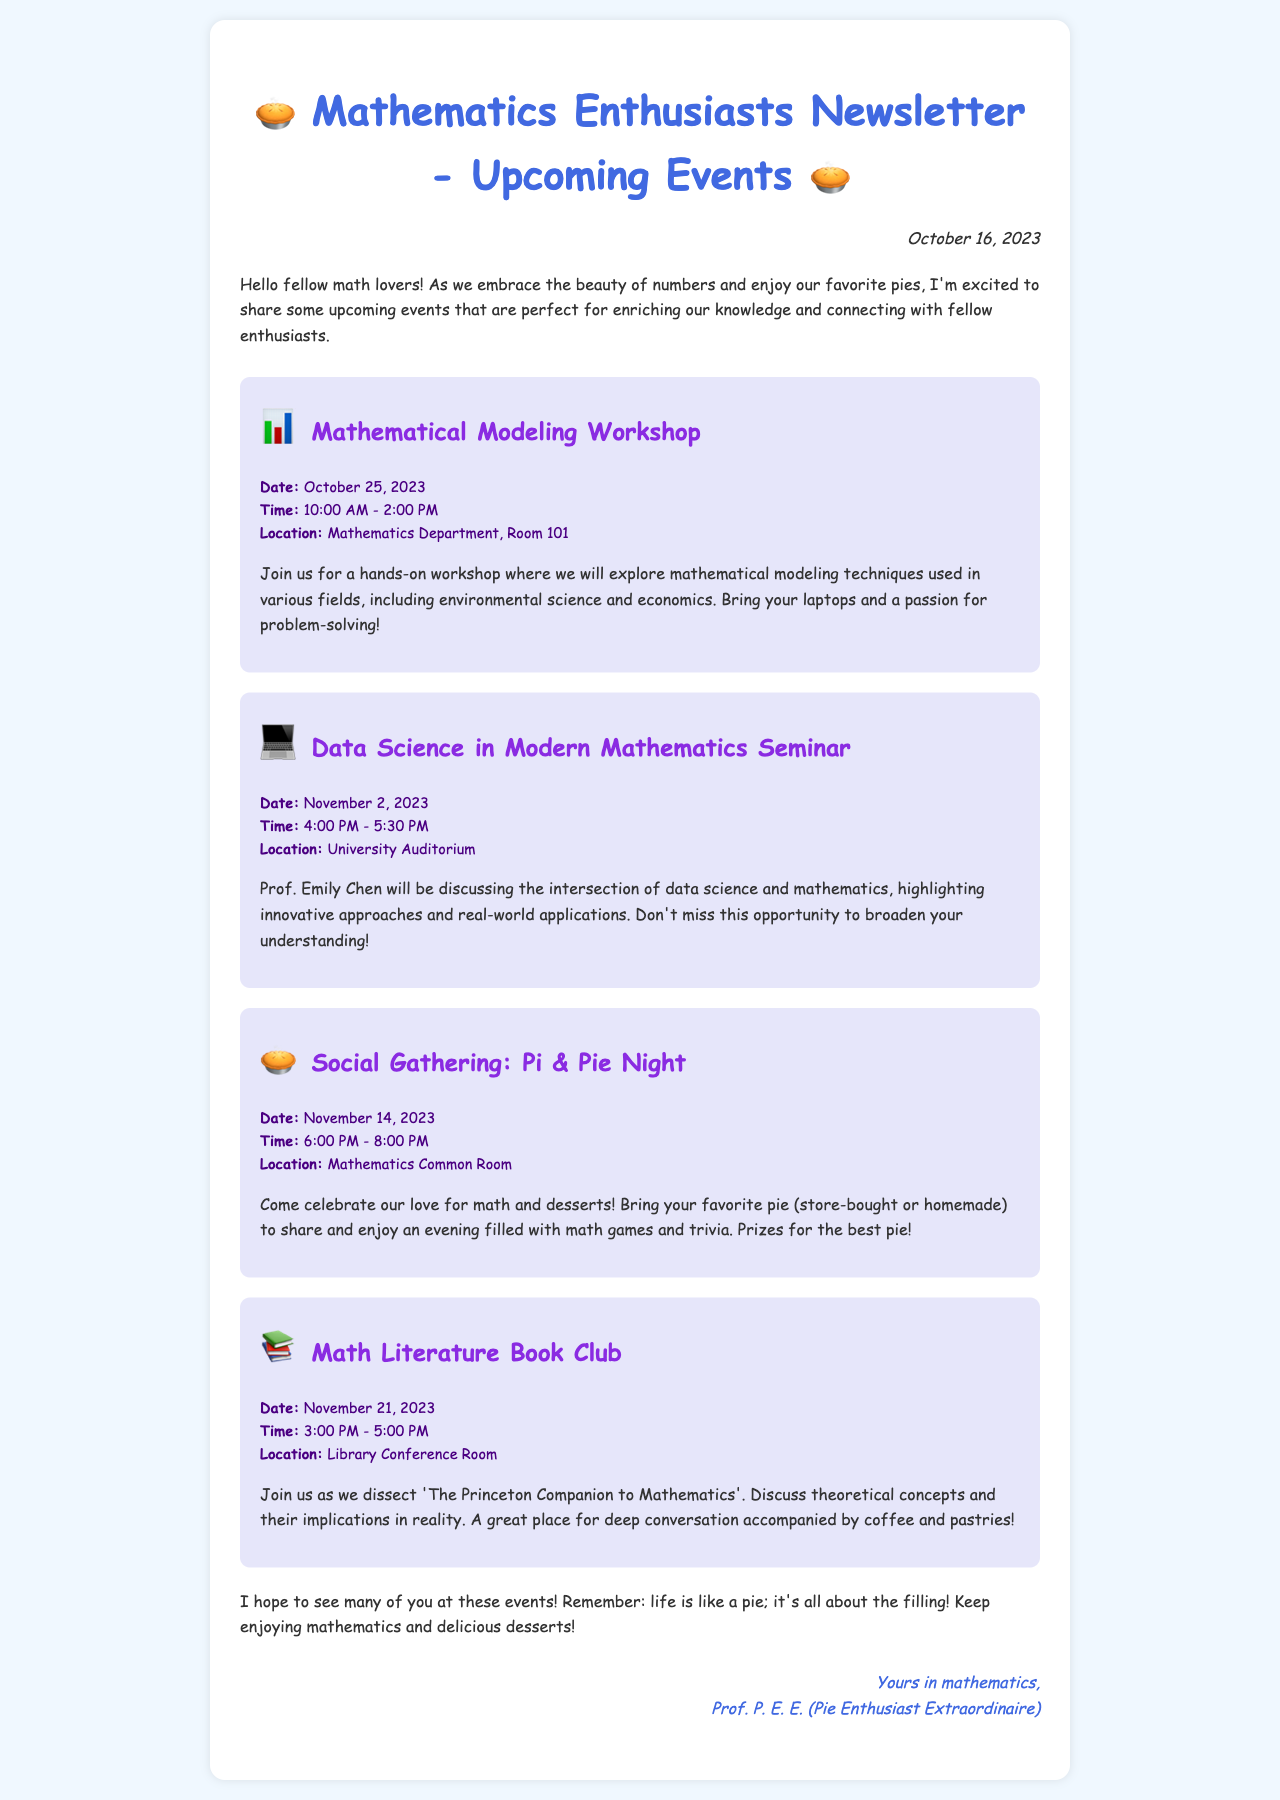What is the date of the Mathematical Modeling Workshop? The date is clearly stated in the event details of the Mathematical Modeling Workshop section.
Answer: October 25, 2023 Who is presenting the Data Science in Modern Mathematics Seminar? The name of the presenter is mentioned in the event details of the seminar section.
Answer: Prof. Emily Chen What time does the Pi & Pie Night event start? The starting time is given in the event details of the Pi & Pie Night section.
Answer: 6:00 PM How long will the Math Literature Book Club meeting last? The duration is implied by the start and end time provided in the event details of the Math Literature Book Club section.
Answer: 2 hours What is required to attend the Social Gathering: Pi & Pie Night? The invitation mentions bringing a favorite pie, indicating participants should bring something.
Answer: Favorite pie What event focuses on hands-on activities? The question targets an event type known for interactive experiences, which is specified in the title of an event.
Answer: Mathematical Modeling Workshop Which event has a prize for the best pie? This information is clearly mentioned in the description of the Social Gathering event details.
Answer: Social Gathering: Pi & Pie Night In which room will the Data Science in Modern Mathematics Seminar take place? The location of the seminar is specified in the event details section.
Answer: University Auditorium What is the name of the newsletter? The newsletter's title is prominently displayed at the top of the document.
Answer: Mathematics Enthusiasts Newsletter - Upcoming Events 